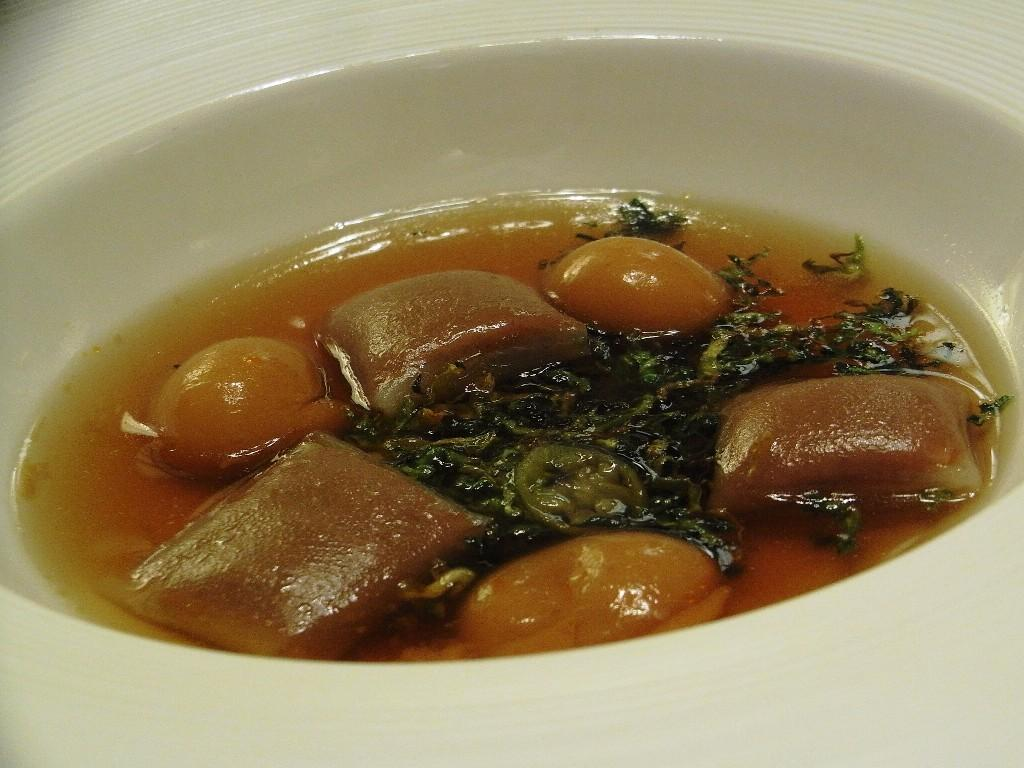What is the main subject of the image? The main subject of the image is a food item. In what type of container is the food item placed? The food item is in a white color bowl. Who is the creator of the impulse that governs the food item in the image? There is no reference to a creator, impulse, or governor in the image, as it only features a food item in a white color bowl. 